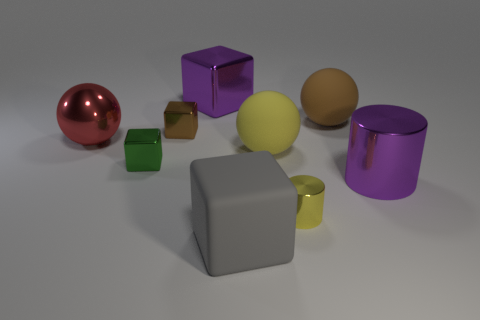Do the big metal cylinder and the big shiny cube have the same color?
Provide a succinct answer. Yes. Is there a cyan matte block that has the same size as the green metal thing?
Give a very brief answer. No. There is a rubber thing that is to the right of the yellow rubber object; is it the same size as the large red ball?
Your answer should be compact. Yes. Is the number of big brown spheres greater than the number of cubes?
Offer a very short reply. No. Are there any yellow shiny objects that have the same shape as the small green object?
Your answer should be very brief. No. What is the shape of the rubber object that is in front of the large yellow ball?
Give a very brief answer. Cube. How many large objects are in front of the big yellow object on the right side of the purple metal thing that is left of the big brown rubber object?
Offer a terse response. 2. Do the tiny shiny thing in front of the green shiny object and the large shiny cube have the same color?
Your answer should be very brief. No. How many other objects are there of the same shape as the big red object?
Keep it short and to the point. 2. How many other objects are the same material as the big red object?
Make the answer very short. 5. 